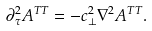<formula> <loc_0><loc_0><loc_500><loc_500>\partial _ { \tau } ^ { 2 } A ^ { T T } = - c _ { \perp } ^ { 2 } \nabla ^ { 2 } A ^ { T T } .</formula> 